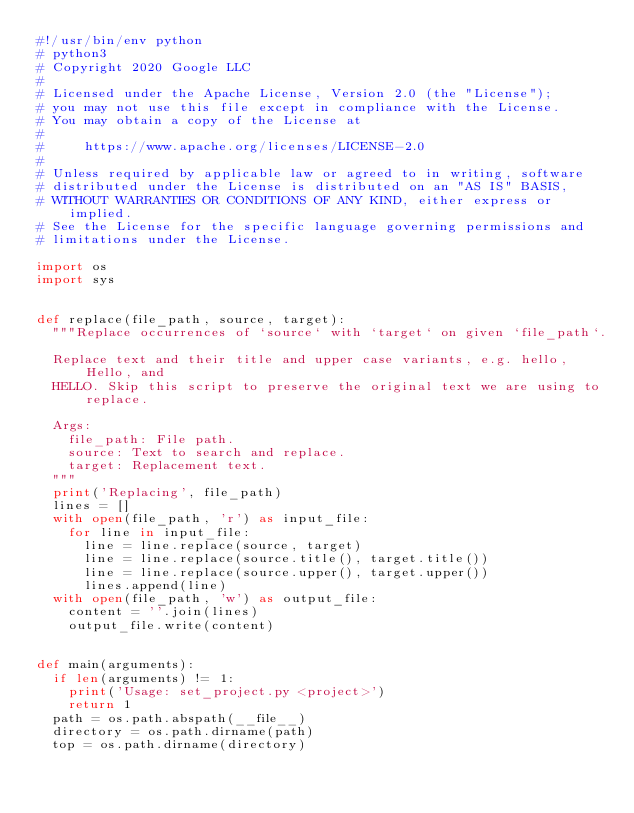Convert code to text. <code><loc_0><loc_0><loc_500><loc_500><_Python_>#!/usr/bin/env python
# python3
# Copyright 2020 Google LLC
#
# Licensed under the Apache License, Version 2.0 (the "License");
# you may not use this file except in compliance with the License.
# You may obtain a copy of the License at
#
#     https://www.apache.org/licenses/LICENSE-2.0
#
# Unless required by applicable law or agreed to in writing, software
# distributed under the License is distributed on an "AS IS" BASIS,
# WITHOUT WARRANTIES OR CONDITIONS OF ANY KIND, either express or implied.
# See the License for the specific language governing permissions and
# limitations under the License.

import os
import sys


def replace(file_path, source, target):
  """Replace occurrences of `source` with `target` on given `file_path`.

  Replace text and their title and upper case variants, e.g. hello, Hello, and
  HELLO. Skip this script to preserve the original text we are using to replace.

  Args:
    file_path: File path.
    source: Text to search and replace.
    target: Replacement text.
  """
  print('Replacing', file_path)
  lines = []
  with open(file_path, 'r') as input_file:
    for line in input_file:
      line = line.replace(source, target)
      line = line.replace(source.title(), target.title())
      line = line.replace(source.upper(), target.upper())
      lines.append(line)
  with open(file_path, 'w') as output_file:
    content = ''.join(lines)
    output_file.write(content)


def main(arguments):
  if len(arguments) != 1:
    print('Usage: set_project.py <project>')
    return 1
  path = os.path.abspath(__file__)
  directory = os.path.dirname(path)
  top = os.path.dirname(directory)</code> 